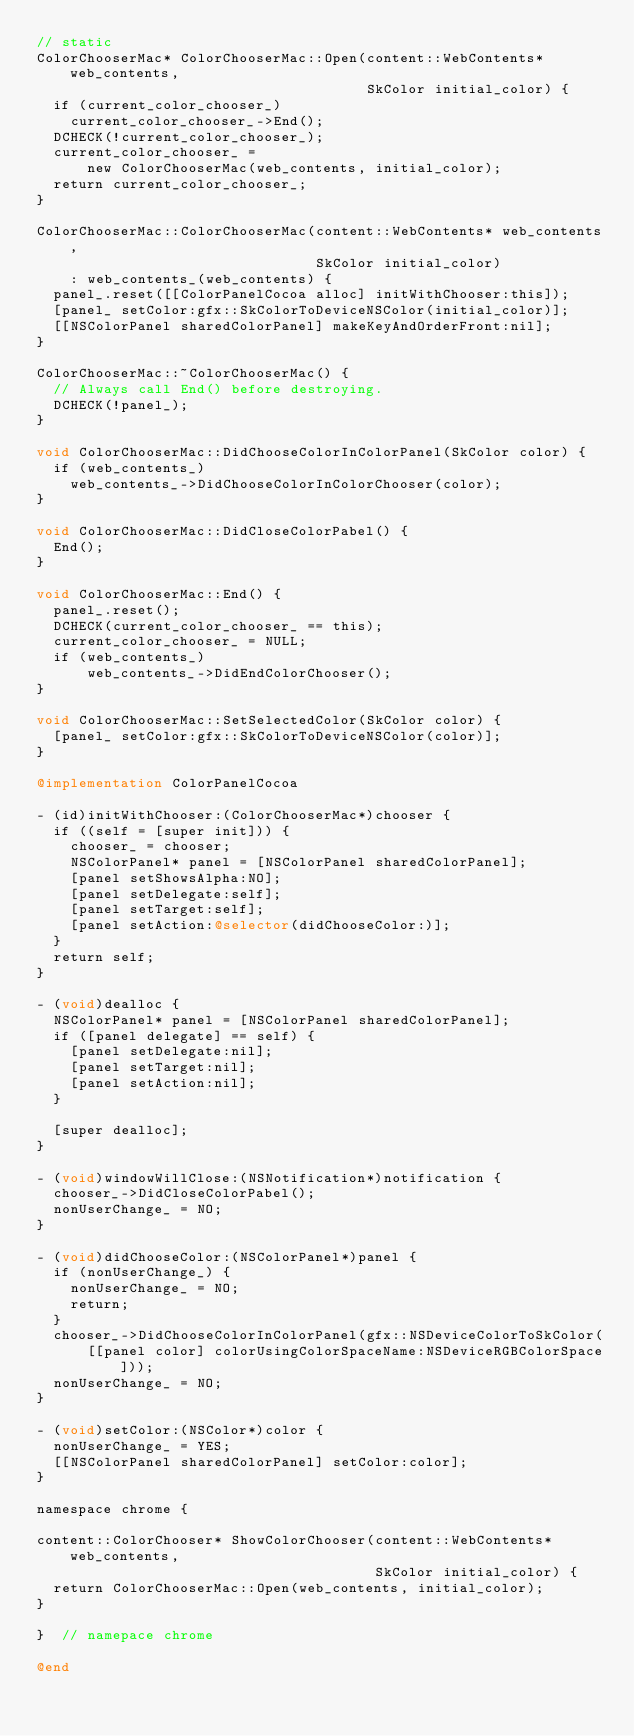<code> <loc_0><loc_0><loc_500><loc_500><_ObjectiveC_>// static
ColorChooserMac* ColorChooserMac::Open(content::WebContents* web_contents,
                                       SkColor initial_color) {
  if (current_color_chooser_)
    current_color_chooser_->End();
  DCHECK(!current_color_chooser_);
  current_color_chooser_ =
      new ColorChooserMac(web_contents, initial_color);
  return current_color_chooser_;
}

ColorChooserMac::ColorChooserMac(content::WebContents* web_contents,
                                 SkColor initial_color)
    : web_contents_(web_contents) {
  panel_.reset([[ColorPanelCocoa alloc] initWithChooser:this]);
  [panel_ setColor:gfx::SkColorToDeviceNSColor(initial_color)];
  [[NSColorPanel sharedColorPanel] makeKeyAndOrderFront:nil];
}

ColorChooserMac::~ColorChooserMac() {
  // Always call End() before destroying.
  DCHECK(!panel_);
}

void ColorChooserMac::DidChooseColorInColorPanel(SkColor color) {
  if (web_contents_)
    web_contents_->DidChooseColorInColorChooser(color);
}

void ColorChooserMac::DidCloseColorPabel() {
  End();
}

void ColorChooserMac::End() {
  panel_.reset();
  DCHECK(current_color_chooser_ == this);
  current_color_chooser_ = NULL;
  if (web_contents_)
      web_contents_->DidEndColorChooser();
}

void ColorChooserMac::SetSelectedColor(SkColor color) {
  [panel_ setColor:gfx::SkColorToDeviceNSColor(color)];
}

@implementation ColorPanelCocoa

- (id)initWithChooser:(ColorChooserMac*)chooser {
  if ((self = [super init])) {
    chooser_ = chooser;
    NSColorPanel* panel = [NSColorPanel sharedColorPanel];
    [panel setShowsAlpha:NO];
    [panel setDelegate:self];
    [panel setTarget:self];
    [panel setAction:@selector(didChooseColor:)];
  }
  return self;
}

- (void)dealloc {
  NSColorPanel* panel = [NSColorPanel sharedColorPanel];
  if ([panel delegate] == self) {
    [panel setDelegate:nil];
    [panel setTarget:nil];
    [panel setAction:nil];
  }

  [super dealloc];
}

- (void)windowWillClose:(NSNotification*)notification {
  chooser_->DidCloseColorPabel();
  nonUserChange_ = NO;
}

- (void)didChooseColor:(NSColorPanel*)panel {
  if (nonUserChange_) {
    nonUserChange_ = NO;
    return;
  }
  chooser_->DidChooseColorInColorPanel(gfx::NSDeviceColorToSkColor(
      [[panel color] colorUsingColorSpaceName:NSDeviceRGBColorSpace]));
  nonUserChange_ = NO;
}

- (void)setColor:(NSColor*)color {
  nonUserChange_ = YES;
  [[NSColorPanel sharedColorPanel] setColor:color];
}

namespace chrome {

content::ColorChooser* ShowColorChooser(content::WebContents* web_contents,
                                        SkColor initial_color) {
  return ColorChooserMac::Open(web_contents, initial_color);
}

}  // namepace chrome

@end
</code> 